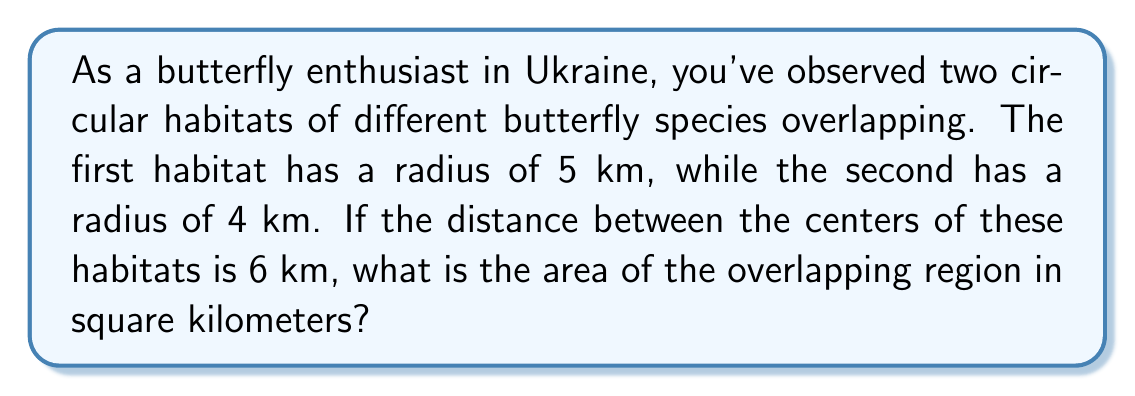Could you help me with this problem? Let's approach this step-by-step:

1) This problem involves calculating the area of overlap between two circles. We can use the formula for the area of intersection of two circles:

   $$A = r_1^2 \arccos(\frac{d^2 + r_1^2 - r_2^2}{2dr_1}) + r_2^2 \arccos(\frac{d^2 + r_2^2 - r_1^2}{2dr_2}) - \frac{1}{2}\sqrt{(-d+r_1+r_2)(d+r_1-r_2)(d-r_1+r_2)(d+r_1+r_2)}$$

   Where $r_1$ and $r_2$ are the radii of the circles, and $d$ is the distance between their centers.

2) We have:
   $r_1 = 5$ km
   $r_2 = 4$ km
   $d = 6$ km

3) Let's substitute these values into our formula:

   $$A = 5^2 \arccos(\frac{6^2 + 5^2 - 4^2}{2 \cdot 6 \cdot 5}) + 4^2 \arccos(\frac{6^2 + 4^2 - 5^2}{2 \cdot 6 \cdot 4}) - \frac{1}{2}\sqrt{(-6+5+4)(6+5-4)(6-5+4)(6+5+4)}$$

4) Simplify:
   $$A = 25 \arccos(\frac{61}{60}) + 16 \arccos(\frac{52}{48}) - \frac{1}{2}\sqrt{3 \cdot 7 \cdot 5 \cdot 15}$$

5) Calculate:
   $$A \approx 25 \cdot 0.2490 + 16 \cdot 0.5150 - \frac{1}{2}\sqrt{1575}$$
   $$A \approx 6.225 + 8.240 - 19.844$$
   $$A \approx 14.465 - 19.844$$
   $$A \approx 12.371$$

6) Round to two decimal places:
   $$A \approx 12.37 \text{ km}^2$$

[asy]
unitsize(10mm);
pair O1 = (0,0), O2 = (6,0);
draw(circle(O1,5));
draw(circle(O2,4));
label("r=5", (-2.5,2.5));
label("r=4", (8,2));
label("d=6", (3,-0.5));
dot(O1); dot(O2);
label("O1", O1, SW);
label("O2", O2, SE);
[/asy]
Answer: 12.37 km² 